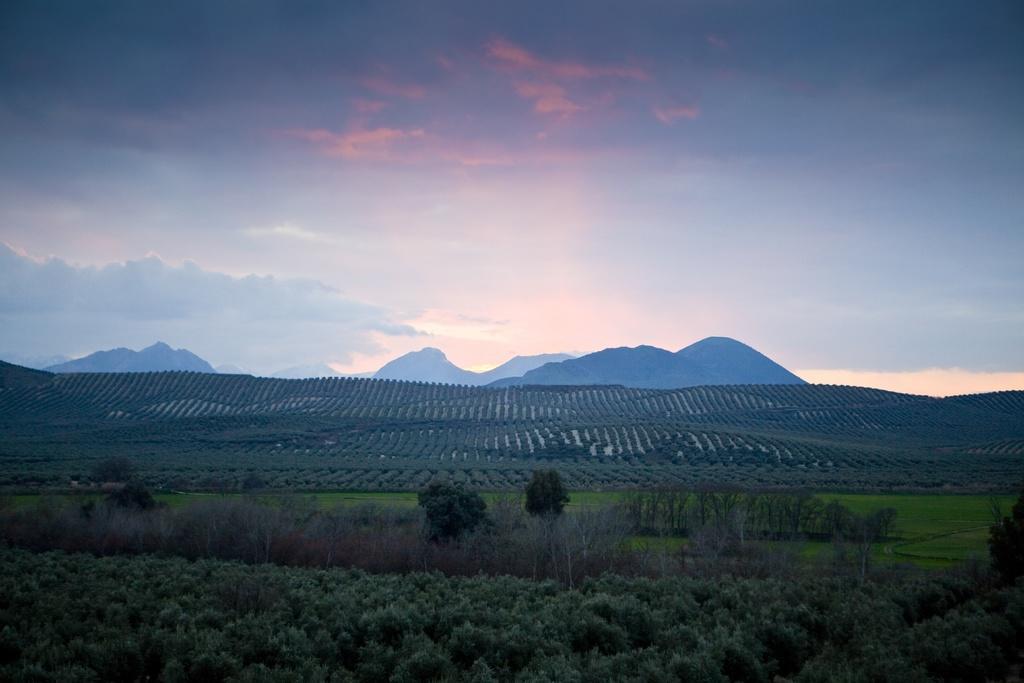In one or two sentences, can you explain what this image depicts? In this image I can see few mountains, few green color trees and the dry trees. The sky is in blue, orange and white color. 